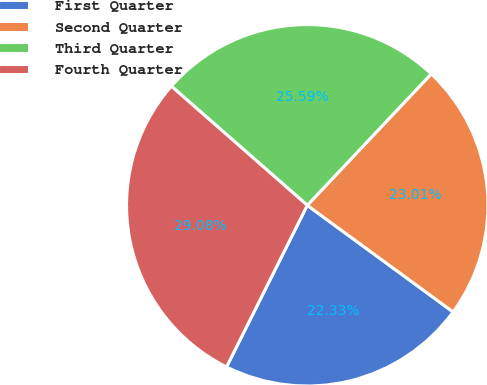Convert chart. <chart><loc_0><loc_0><loc_500><loc_500><pie_chart><fcel>First Quarter<fcel>Second Quarter<fcel>Third Quarter<fcel>Fourth Quarter<nl><fcel>22.33%<fcel>23.01%<fcel>25.59%<fcel>29.08%<nl></chart> 